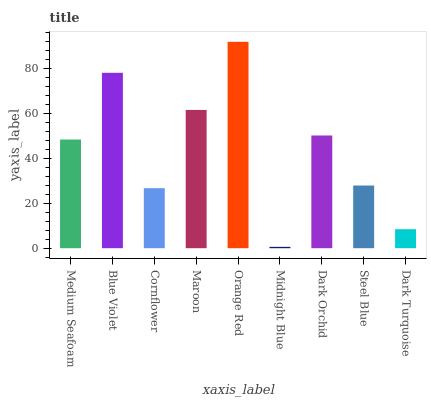Is Blue Violet the minimum?
Answer yes or no. No. Is Blue Violet the maximum?
Answer yes or no. No. Is Blue Violet greater than Medium Seafoam?
Answer yes or no. Yes. Is Medium Seafoam less than Blue Violet?
Answer yes or no. Yes. Is Medium Seafoam greater than Blue Violet?
Answer yes or no. No. Is Blue Violet less than Medium Seafoam?
Answer yes or no. No. Is Medium Seafoam the high median?
Answer yes or no. Yes. Is Medium Seafoam the low median?
Answer yes or no. Yes. Is Cornflower the high median?
Answer yes or no. No. Is Cornflower the low median?
Answer yes or no. No. 